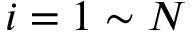Convert formula to latex. <formula><loc_0><loc_0><loc_500><loc_500>i = 1 \sim N</formula> 